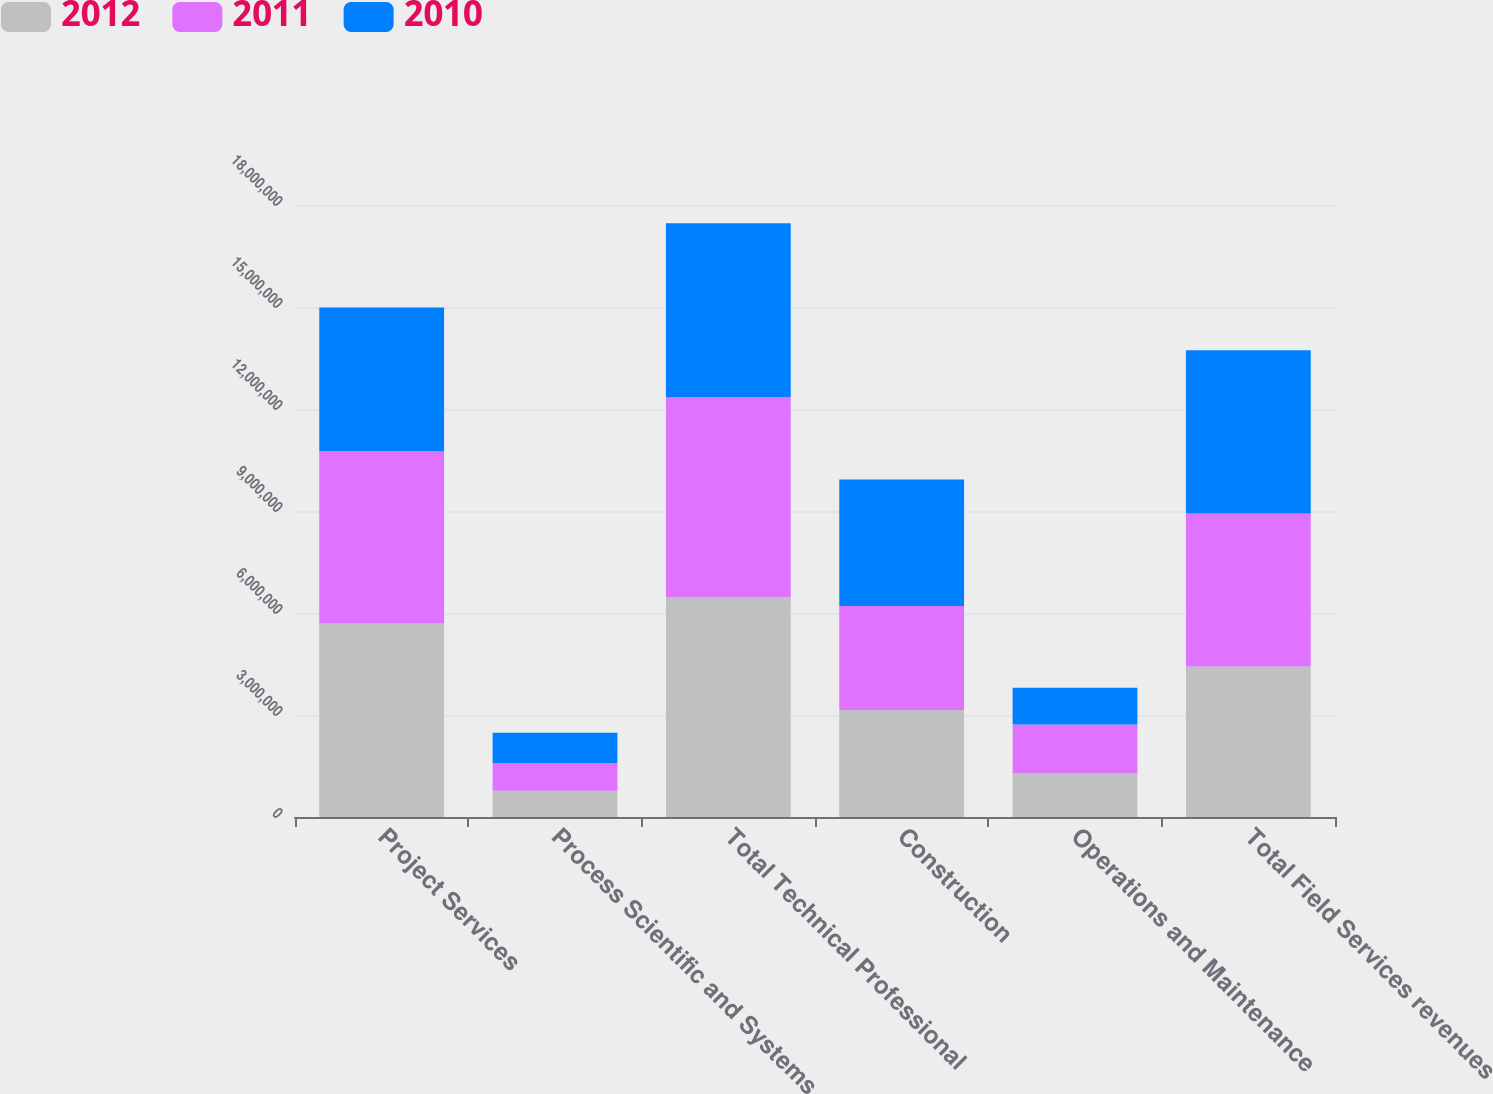Convert chart to OTSL. <chart><loc_0><loc_0><loc_500><loc_500><stacked_bar_chart><ecel><fcel>Project Services<fcel>Process Scientific and Systems<fcel>Total Technical Professional<fcel>Construction<fcel>Operations and Maintenance<fcel>Total Field Services revenues<nl><fcel>2012<fcel>5.69342e+06<fcel>772031<fcel>6.46545e+06<fcel>3.14531e+06<fcel>1.28302e+06<fcel>4.42833e+06<nl><fcel>2011<fcel>5.07058e+06<fcel>815561<fcel>5.88614e+06<fcel>3.06082e+06<fcel>1.43471e+06<fcel>4.49553e+06<nl><fcel>2010<fcel>4.2249e+06<fcel>888405<fcel>5.1133e+06<fcel>3.7221e+06<fcel>1.08011e+06<fcel>4.80221e+06<nl></chart> 